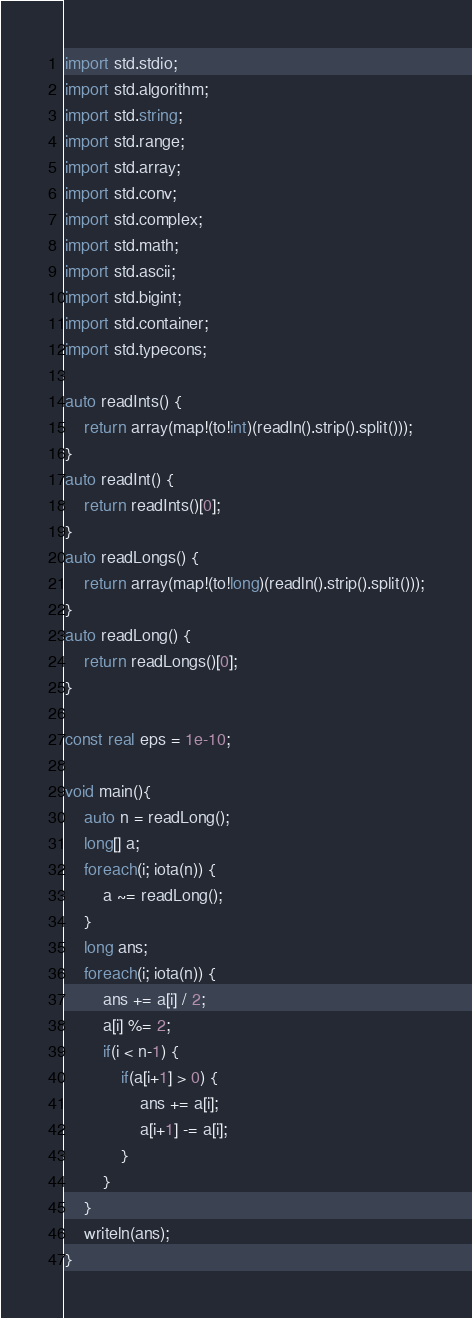Convert code to text. <code><loc_0><loc_0><loc_500><loc_500><_D_>import std.stdio;
import std.algorithm;
import std.string;
import std.range;
import std.array;
import std.conv;
import std.complex;
import std.math;
import std.ascii;
import std.bigint;
import std.container;
import std.typecons;

auto readInts() {
	return array(map!(to!int)(readln().strip().split()));
}
auto readInt() {
	return readInts()[0];
}
auto readLongs() {
	return array(map!(to!long)(readln().strip().split()));
}
auto readLong() {
	return readLongs()[0];
}

const real eps = 1e-10;

void main(){
    auto n = readLong();
    long[] a;
    foreach(i; iota(n)) {
        a ~= readLong();
    }
    long ans;
    foreach(i; iota(n)) {
        ans += a[i] / 2;
        a[i] %= 2;
        if(i < n-1) {
            if(a[i+1] > 0) {
                ans += a[i];
                a[i+1] -= a[i];
            }
        }
    }
    writeln(ans);
}

</code> 